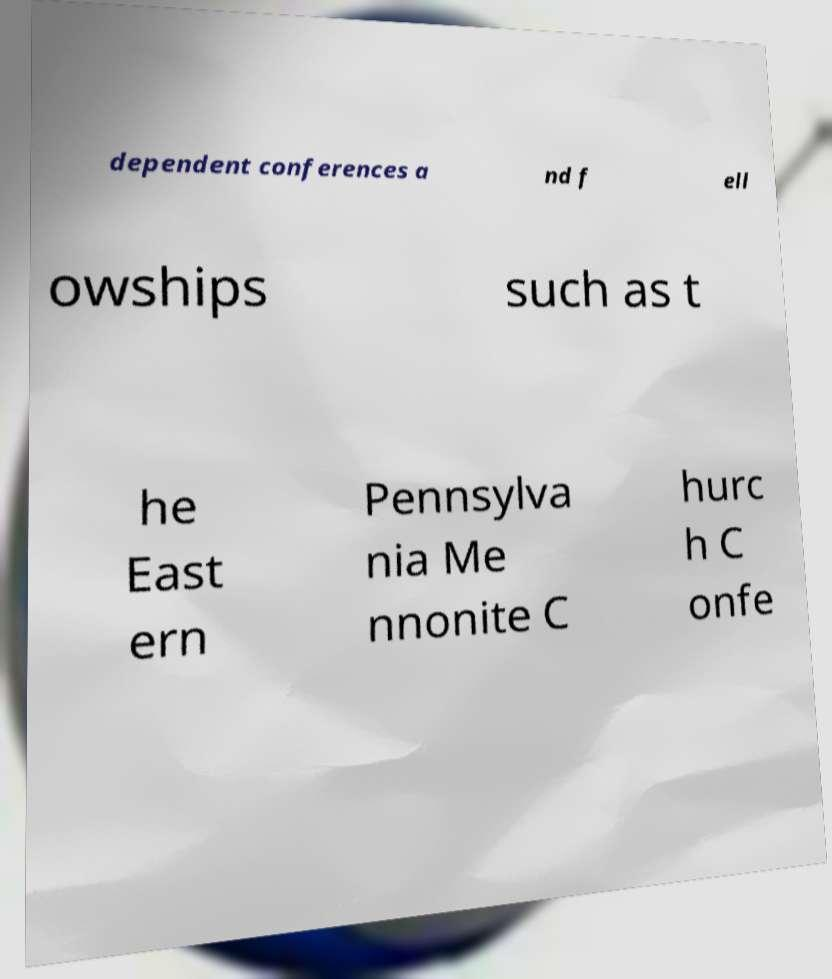I need the written content from this picture converted into text. Can you do that? dependent conferences a nd f ell owships such as t he East ern Pennsylva nia Me nnonite C hurc h C onfe 